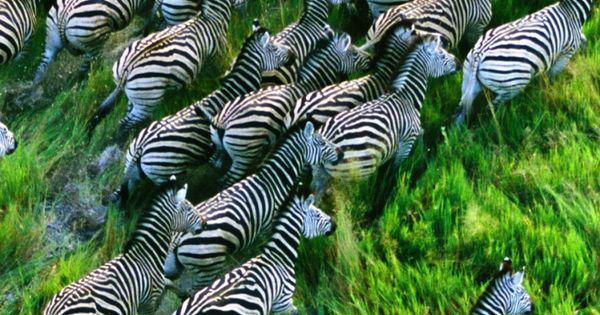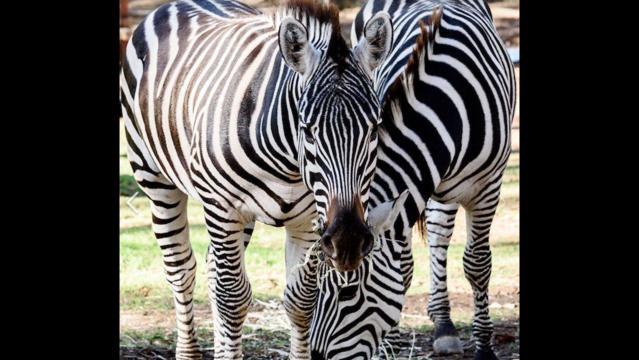The first image is the image on the left, the second image is the image on the right. Assess this claim about the two images: "The left image includes a zebra colt standing and facing leftward, and the right image contains a rightward-facing zebra standing closest in the foreground.". Correct or not? Answer yes or no. No. The first image is the image on the left, the second image is the image on the right. Considering the images on both sides, is "In the left image there are two or more zebras moving forward in the same direction." valid? Answer yes or no. Yes. 